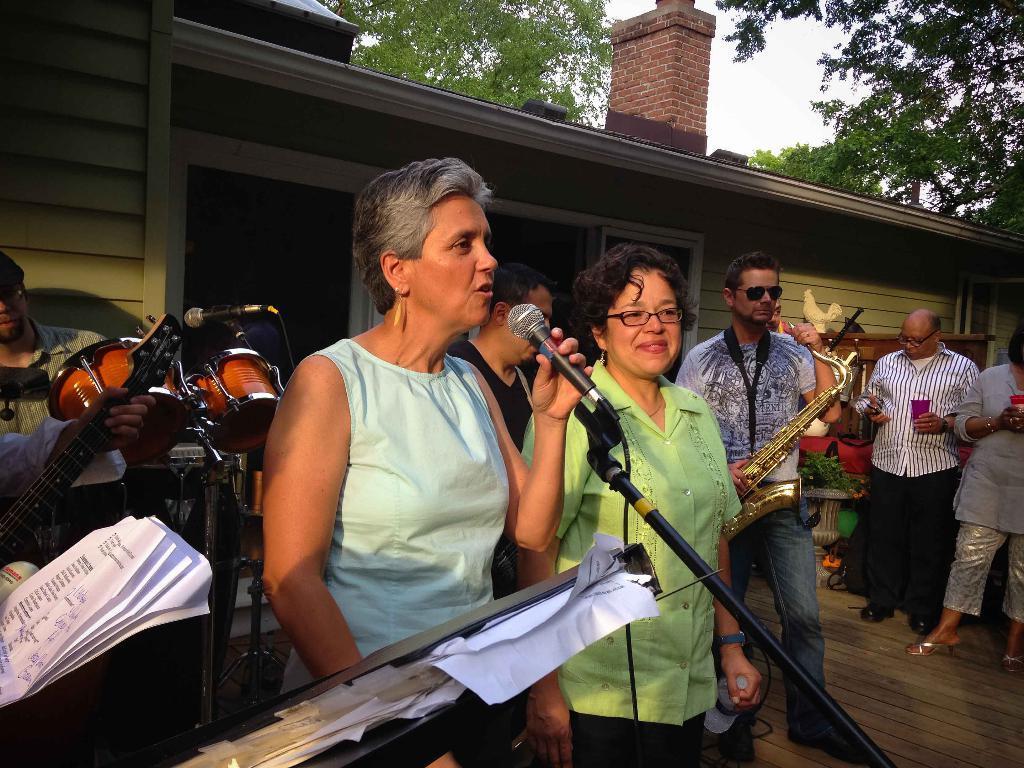How would you summarize this image in a sentence or two? In this image a woman is holding a mike stand. Beside her there is a woman holding a bottle. There is a person holding a musical instrument is standing on the wooden floor. Right side two persons are standing and they are holding some object in their hands. Behind them there is a wooden furniture having an object on it. Beside them there is a pot having a plant in it. Left side a person is holding a guitar. Behind him there is a person. Before him there is a musical instrument and a mike stand. Top of the image there are few trees. Behind there is sky. Bottom of the image there is a board having few papers on it. 